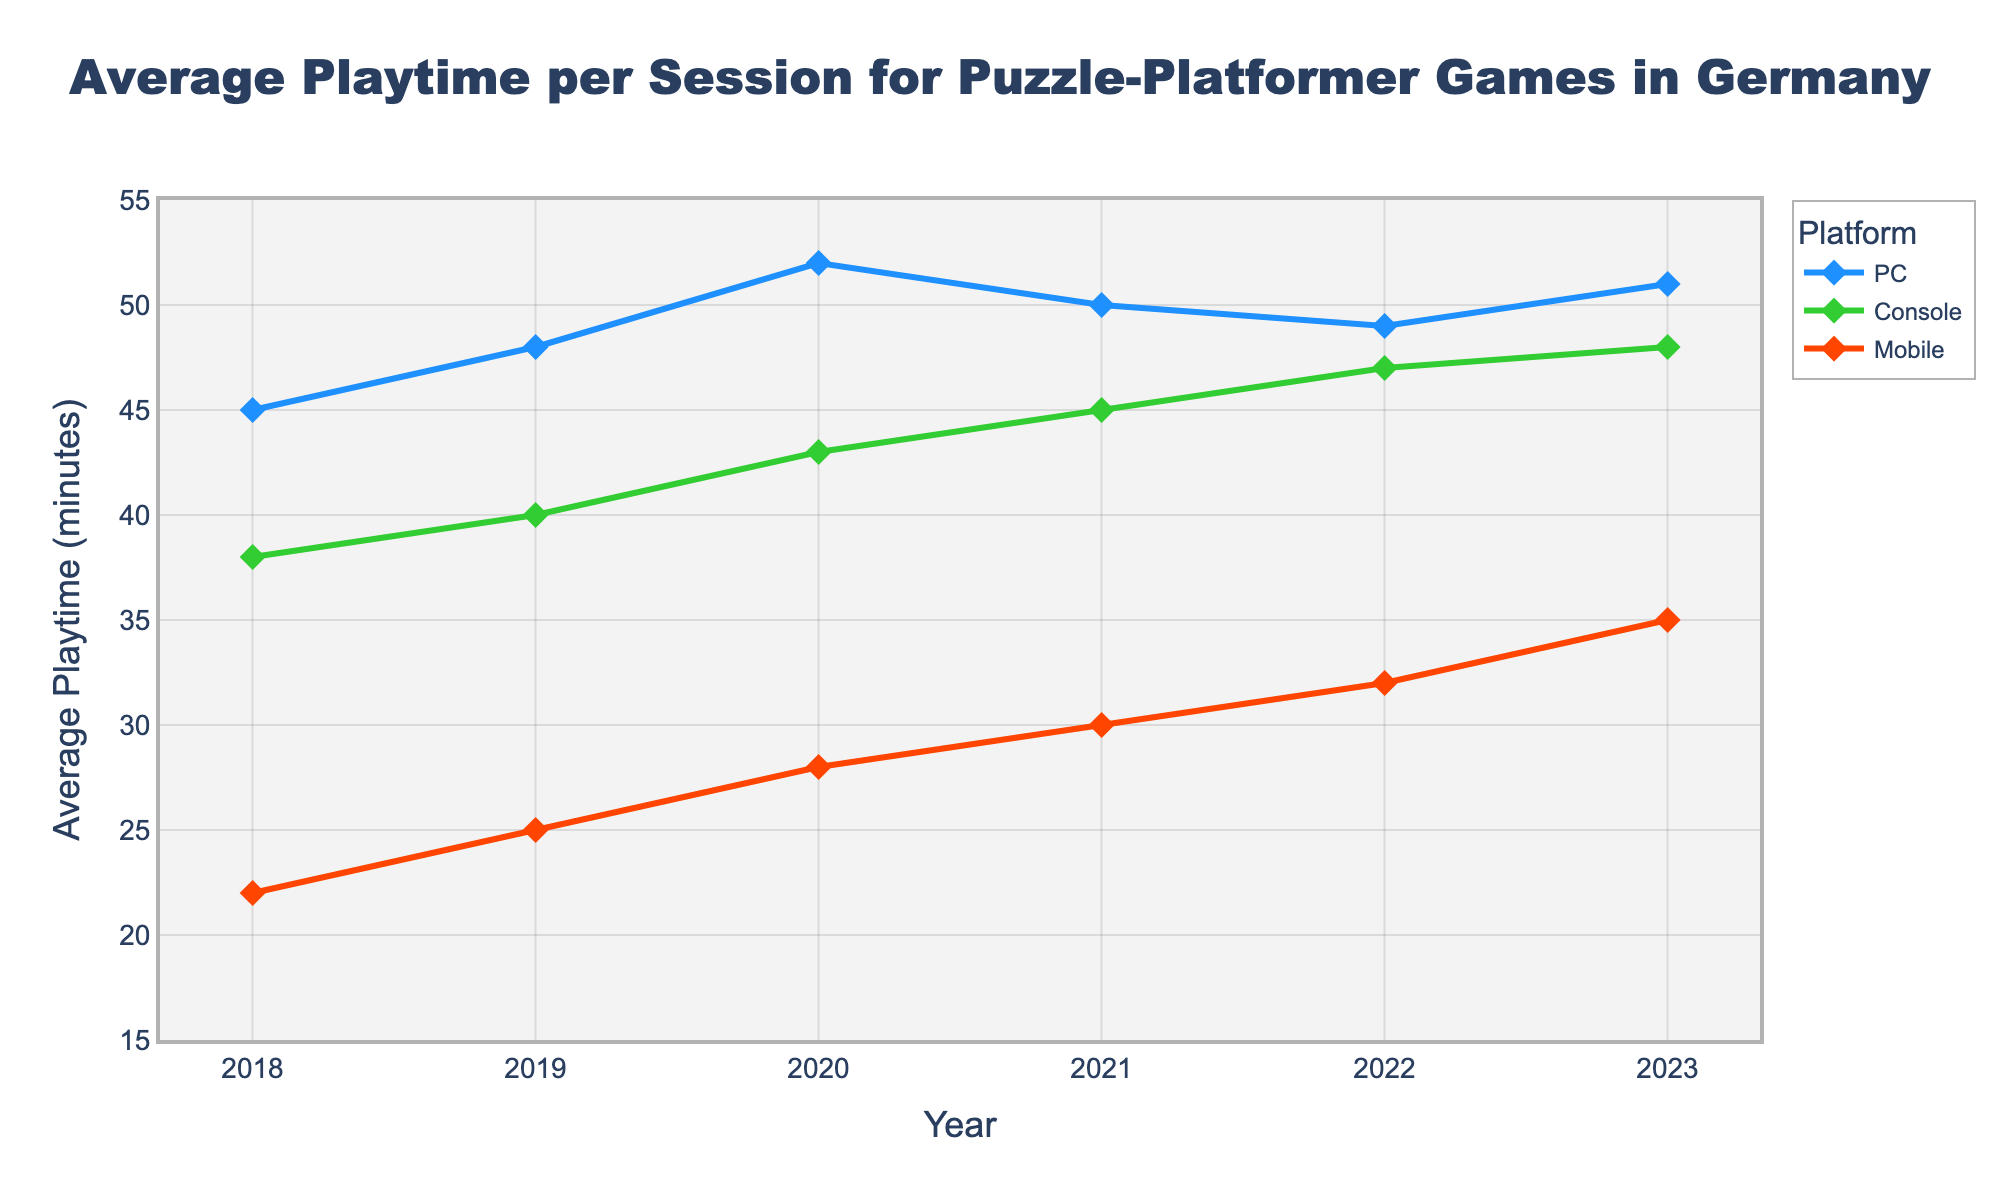What was the average playtime per session for Mobile in 2023? Look at the Mobile line for the year 2023, which is at the rightmost end. The y-axis value at this point is 35 minutes.
Answer: 35 Between which years did Console gaming see the highest increase in average playtime per session? Observe the Console line and compare the annual increments. From 2021 to 2022, the playtime increased from 45 to 47 minutes, and from 2022 to 2023, it increased from 47 to 48 minutes. The highest annual increase is between 2022 and 2023.
Answer: 2022 to 2023 Which platform consistently shows the highest playtime over the years? Compare the y-values of all platforms yearly; the PC consistently has the highest average playtime per session from 2018 to 2023.
Answer: PC What is the difference in average playtime per session between PC and Mobile in 2021? Find the y-values for both PC and Mobile in 2021: PC is 50 and Mobile is 30. Calculate the difference: 50 - 30 = 20.
Answer: 20 How did the average playtime per session for PC change from 2018 to 2023? Look at the start and end points for PC: in 2018 it is 45 minutes, and in 2023, it is 51 minutes. The change is 51 - 45 = 6 minutes.
Answer: Increased by 6 minutes Which year shows the smallest gap between Console and PC average playtime per session? Calculate the differences between PC and Console y-values for each year: 
2018: 45 - 38 = 7
2019: 48 - 40 = 8
2020: 52 - 43 = 9
2021: 50 - 45 = 5
2022: 49 - 47 = 2
2023: 51 - 48 = 3
The smallest gap is in 2022 with a difference of 2 minutes.
Answer: 2022 By how many minutes did Mobile gaming playtime per session increase from 2019 to 2023? Mobile playtime in 2019 was 25 minutes, and in 2023, it was 35 minutes. The increase is 35 - 25 = 10 minutes.
Answer: 10 Which platform had the largest increase in average playtime from 2018 to 2023? Calculate the net increase for each platform:
PC: 51 - 45 = 6
Console: 48 - 38 = 10
Mobile: 35 - 22 = 13
Mobile had the largest increase (13 minutes).
Answer: Mobile In which year was the average playtime per session for Console higher than that for Mobile by more than 20 minutes? Calculate the differences for all years:
2018: 38 - 22 = 16
2019: 40 - 25 = 15
2020: 43 - 28 = 15
2021: 45 - 30 = 15
2022: 47 - 32 = 15
2023: 48 - 35 = 13
No year shows a difference greater than 20 minutes.
Answer: None 